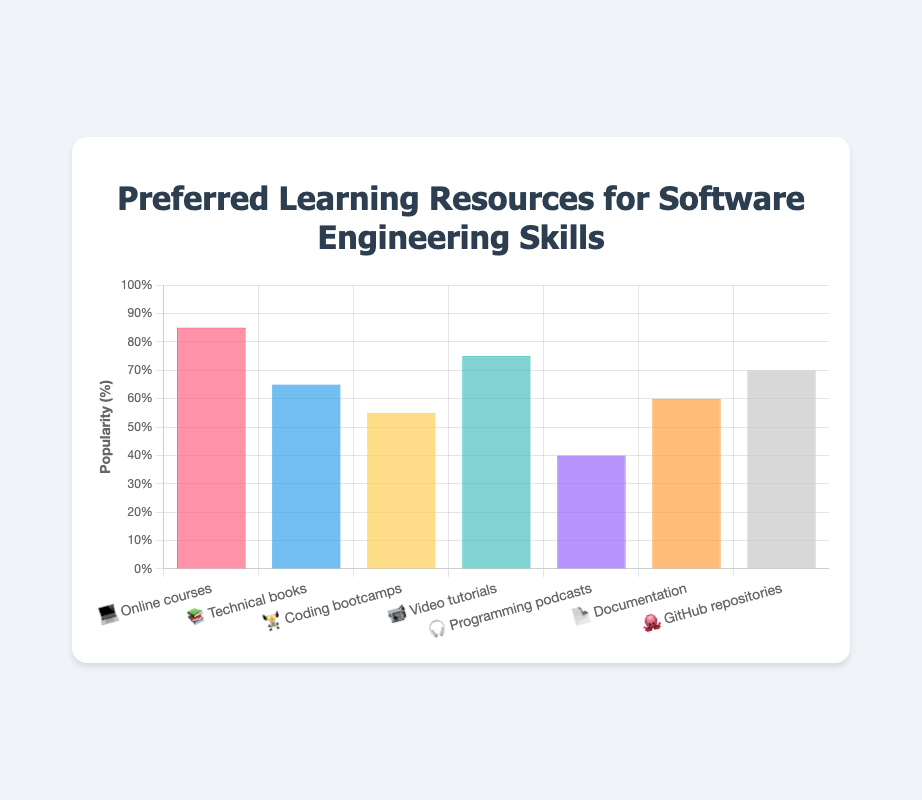Which learning resource is represented by the laptop emoji (💻)? The laptop emoji (💻) corresponds to "Online courses" in the figure.
Answer: Online courses How popular are technical books (📚) as a learning resource? Technical books (📚) have a popularity percentage of 65%, as indicated by the value on the bar related to them.
Answer: 65% Of the learning resources that have a device or object emoji, which one has the highest popularity percentage? By comparing the popularity values, "Online courses" (💻) have the highest percentage at 85%.
Answer: Online courses What is the title of the chart? The title of the chart is clearly written at the top as "Preferred Learning Resources for Software Engineering Skills."
Answer: Preferred Learning Resources for Software Engineering Skills By how much does the popularity of video tutorials (📹) exceed that of programming podcasts (🎧)? Video tutorials (📹) have a popularity of 75%, while programming podcasts (🎧) have 40%. The difference is 75% - 40% = 35%.
Answer: 35% Rank the learning resources from most to least popular. The popularity percentages are: Online courses (85%), Video tutorials (75%), GitHub repositories (70%), Technical books (65%), Documentation (60%), Coding bootcamps (55%), Programming podcasts (40%). So the ranking is:
1. Online courses
2. Video tutorials
3. GitHub repositories
4. Technical books
5. Documentation
6. Coding bootcamps
7. Programming podcasts
Answer: 1. Online courses, 2. Video tutorials, 3. GitHub repositories, 4. Technical books, 5. Documentation, 6. Coding bootcamps, 7. Programming podcasts What is the average popularity of all the learning resources? Sum the popularity percentages of all the resources: 85 + 65 + 55 + 75 + 40 + 60 + 70 = 450, then divide by the number of resources, which is 7. The average is 450 / 7 ≈ 64.29%.
Answer: 64.29% Which learning resource has the smallest popularity percentage and what is it? The bar with the smallest height corresponds to "Programming podcasts" (🎧), which have a popularity percentage of 40%.
Answer: Programming podcasts Are there more learning resources with a popularity above or below 60%? There are 5 learning resources with popularity above 60% (Online courses, Technical books, Video tutorials, GitHub repositories, and Documentation) and 2 below 60% (Coding bootcamps, Programming podcasts). So more resources are above 60%.
Answer: Above 60% What is the total percentage popularity when combining "GitHub repositories" (🐙) and "Coding bootcamps" (🏋️)? The popularity of GitHub repositories (🐙) is 70%, and Coding bootcamps (🏋️) is 55%. Adding these together yields 70% + 55% = 125%.
Answer: 125% 